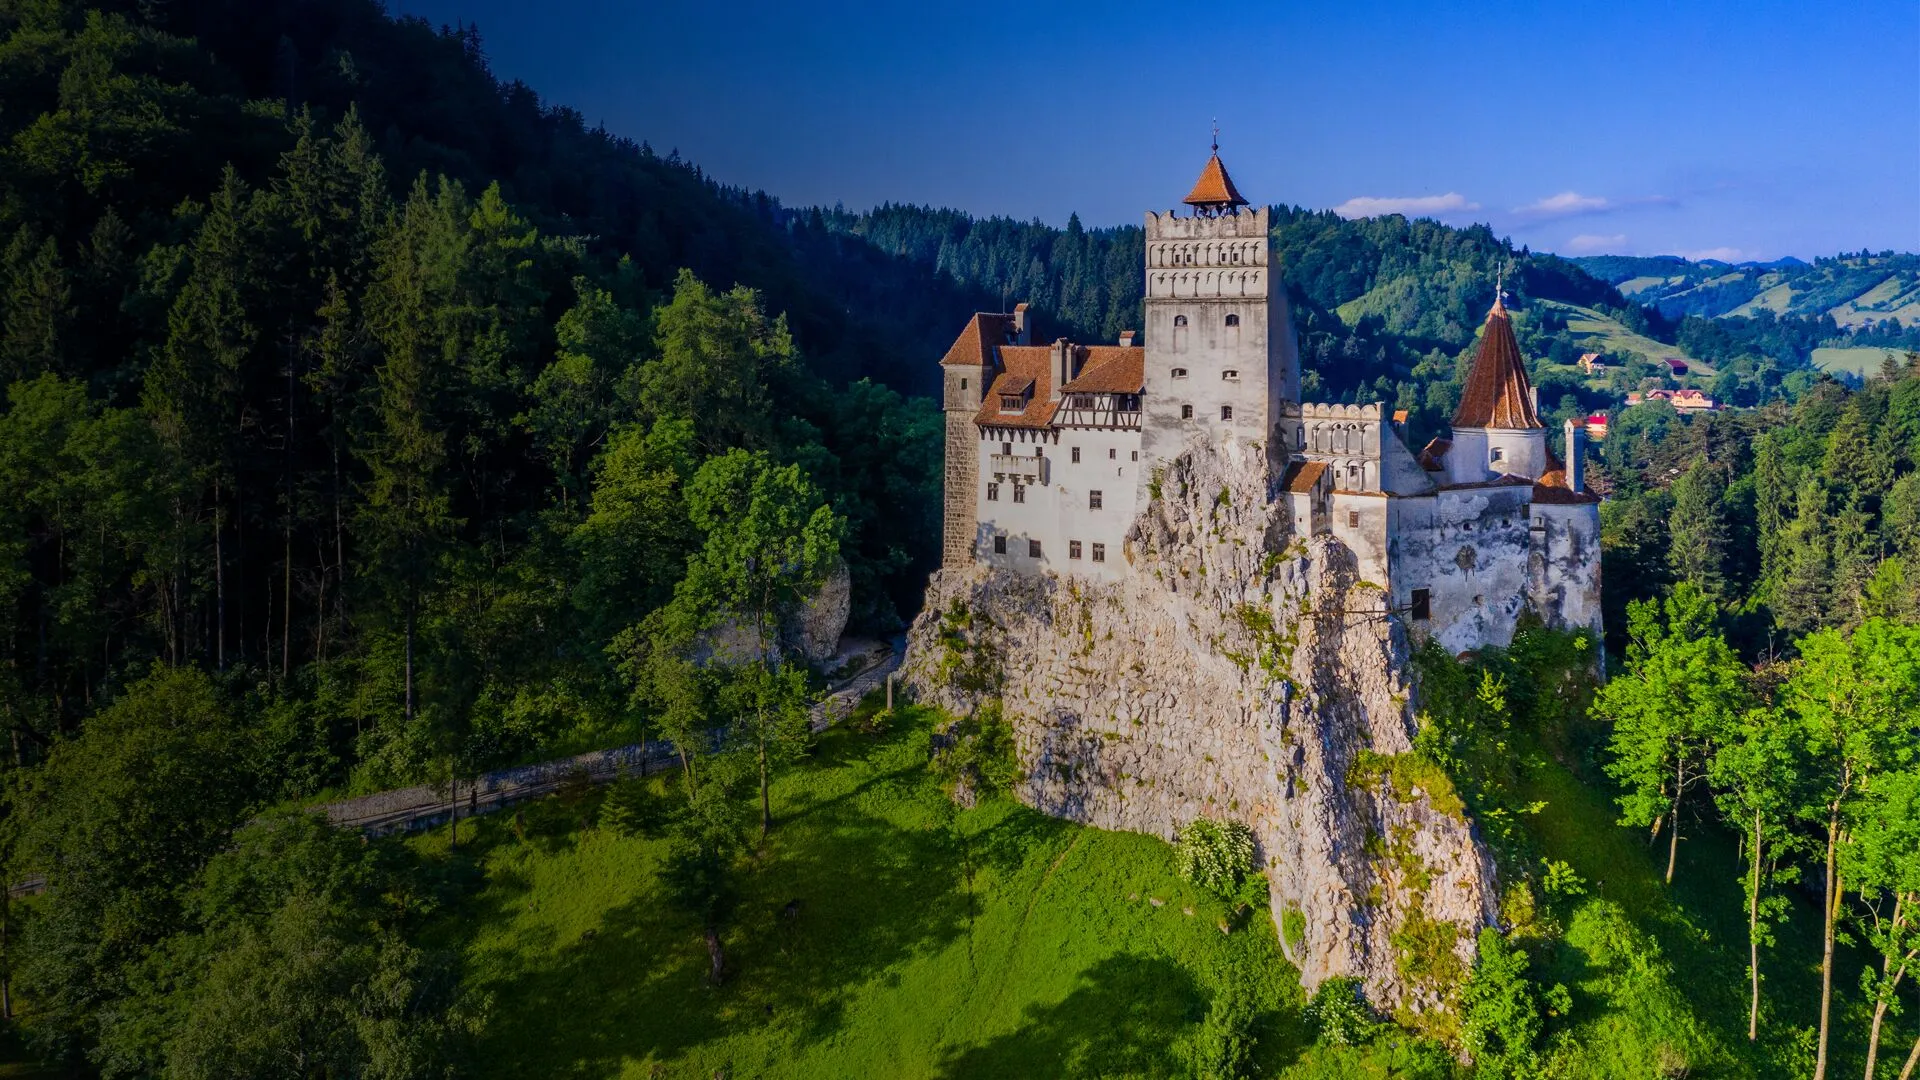Imagine you are a bird flying over the castle. What do you see? As a bird gliding above Bran Castle, you see the castle's towers piercing the clear blue sky. Below, the castle's orange-tiled roofs and white walls form a stark but beautiful contrast against the surrounding green forests. The sunlight casts soft shadows, creating an interplay of light and dark across the rugged cliff side. To the east, you see the sprawling woods that seem to go on forever, while to the west, the rolling hills and scattered villages paint a picturesque landscape. The melodic sound of chirping birds and rustling leaves accompanies your flight as you witness the castle's grandeur from a unique, aerial vantage point. 